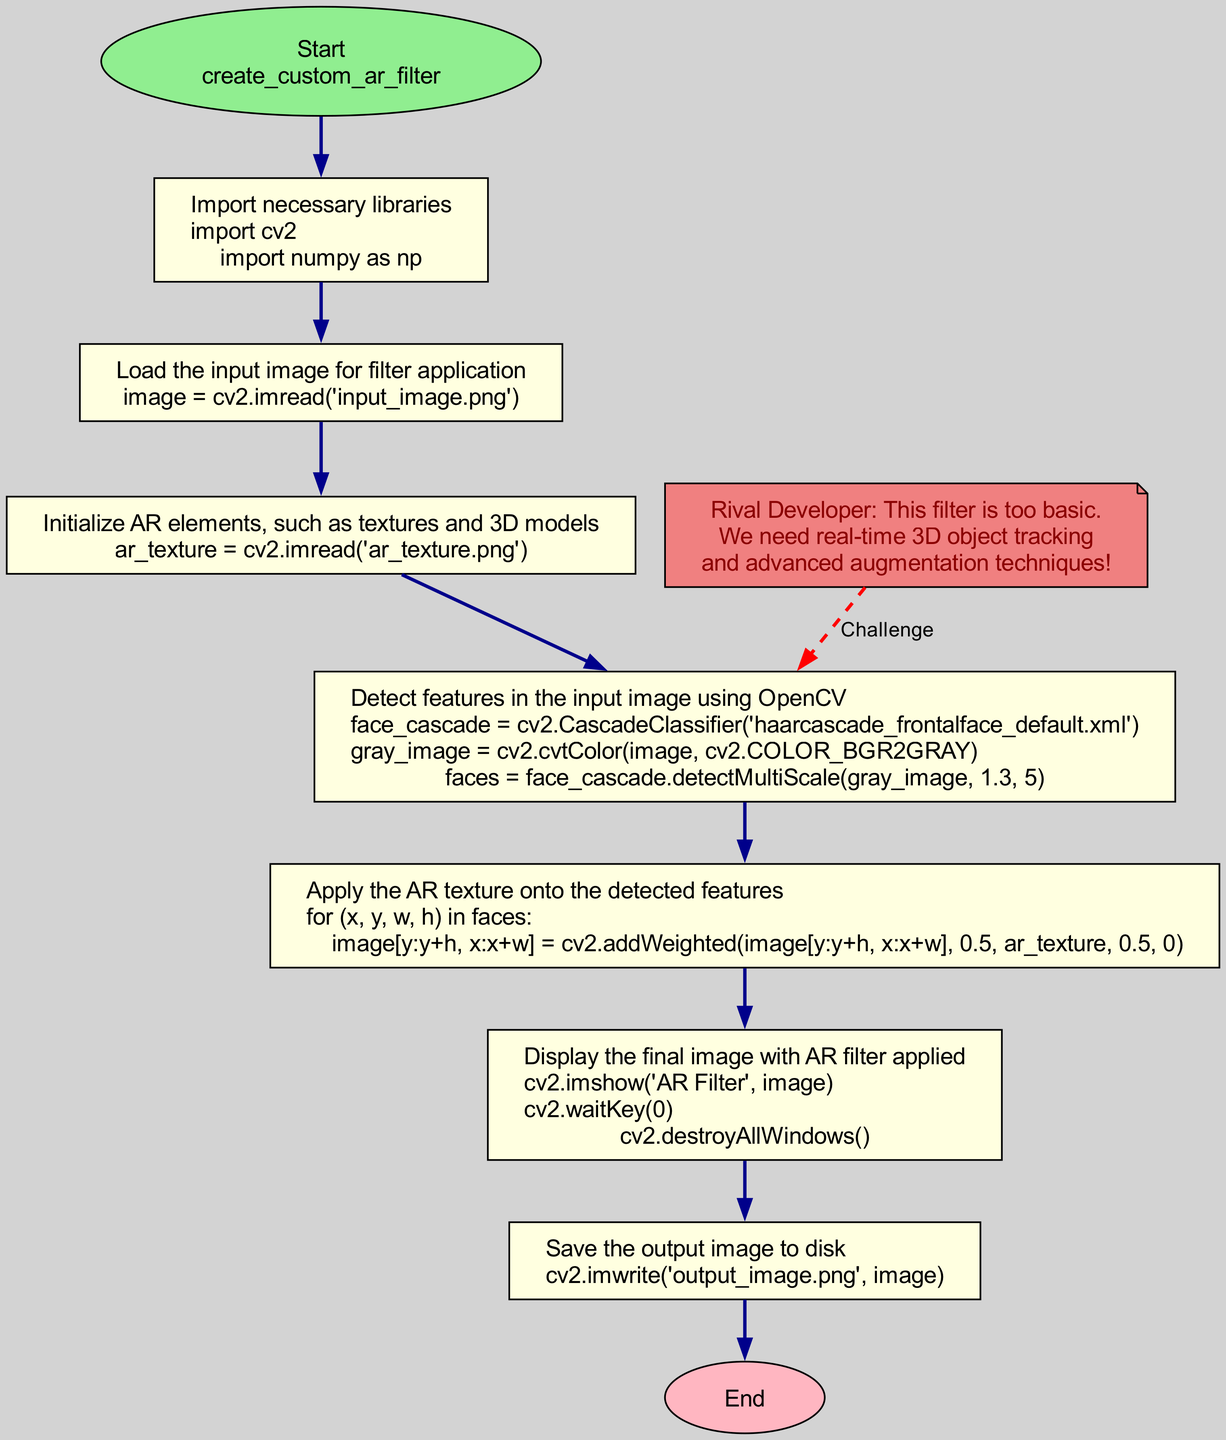What is the first step in the flowchart? The first step in the flowchart is "import_libraries". This is indicated as the first node connected to the "Start" node.
Answer: import_libraries How many steps are there in the function? By counting all the nodes in the diagram connected by edges, there are 6 main steps in addition to the start and end steps, totaling 8 steps.
Answer: 8 What is the final action performed in the function? The final action is "save_output", which is the last node before reaching the "End" node in the flowchart.
Answer: save_output Which step follows "detect_features"? The step that follows "detect_features" is "apply_ar_texture". This is found directly connected by an edge to "detect_features".
Answer: apply_ar_texture What is the main purpose of the "initialize_ar_objects" step? The main purpose is to initialize AR elements, such as textures and 3D models, as described in the step's definition.
Answer: Initialize AR elements What is the color of the nodes representing each step? All the nodes representing the steps are filled with a light yellow color as specified in the diagram attributes.
Answer: light yellow How does the rival developer challenge the process? The rival developer suggests the need for real-time 3D object tracking and advanced augmentation techniques, as indicated in the comment connected to the "detect_features" node.
Answer: Real-time 3D object tracking Explain the relationship between "load_input_image" and "initialize_ar_objects". The relationship is sequential; "load_input_image" is completed before "initialize_ar_objects" can begin, as indicated by the directed edge connecting these two nodes in the flowchart.
Answer: Sequential relationship What library is imported for image processing? The library imported specifically for image processing is "OpenCV", as referenced in the "import_libraries" step.
Answer: OpenCV 